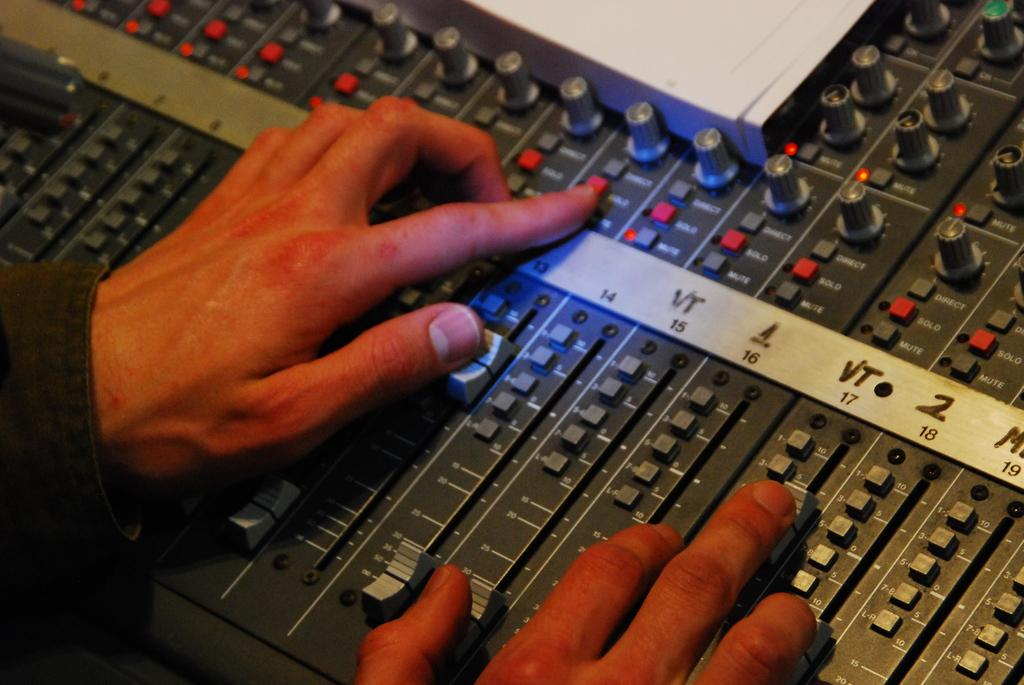<image>
Give a short and clear explanation of the subsequent image. Person with his finger under a knob that says VT. 